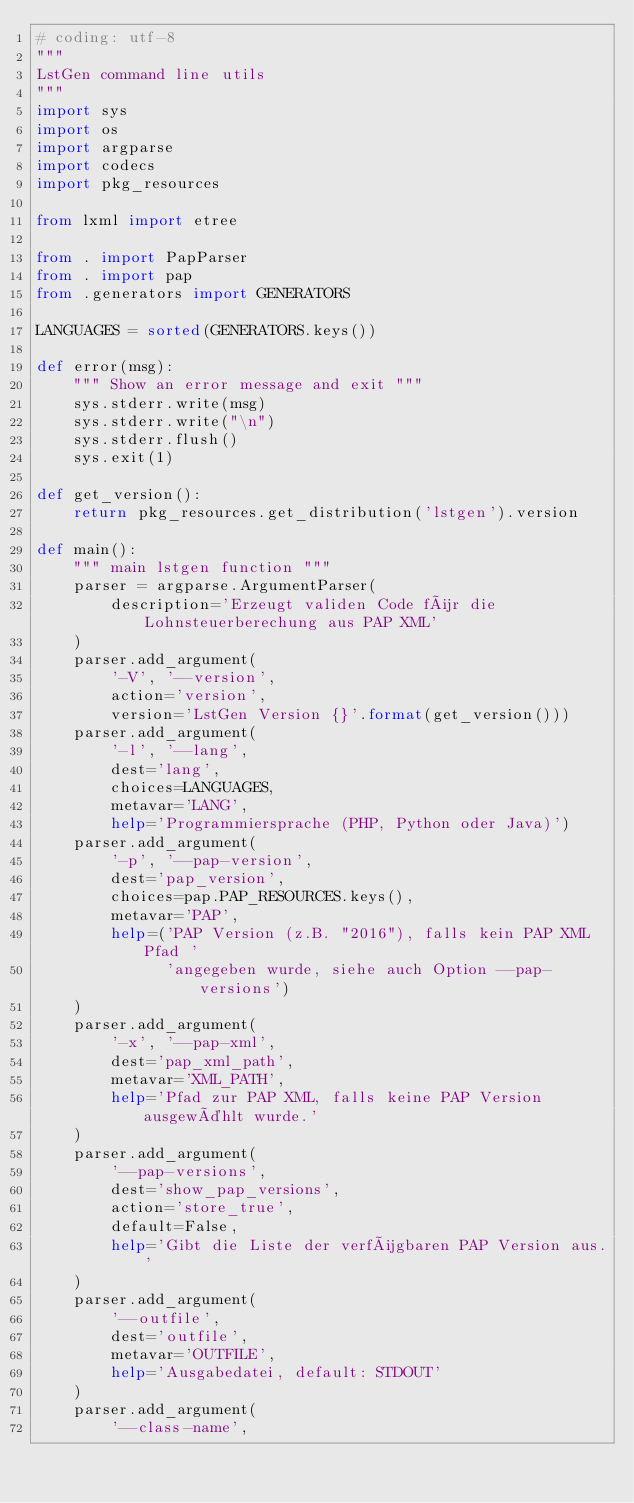<code> <loc_0><loc_0><loc_500><loc_500><_Python_># coding: utf-8
"""
LstGen command line utils
"""
import sys
import os
import argparse
import codecs
import pkg_resources

from lxml import etree

from . import PapParser
from . import pap
from .generators import GENERATORS

LANGUAGES = sorted(GENERATORS.keys())

def error(msg):
    """ Show an error message and exit """
    sys.stderr.write(msg)
    sys.stderr.write("\n")
    sys.stderr.flush()
    sys.exit(1)

def get_version():
    return pkg_resources.get_distribution('lstgen').version

def main():
    """ main lstgen function """
    parser = argparse.ArgumentParser(
        description='Erzeugt validen Code für die Lohnsteuerberechung aus PAP XML'
    )
    parser.add_argument(
        '-V', '--version',
        action='version',
        version='LstGen Version {}'.format(get_version()))
    parser.add_argument(
        '-l', '--lang',
        dest='lang',
        choices=LANGUAGES,
        metavar='LANG',
        help='Programmiersprache (PHP, Python oder Java)')
    parser.add_argument(
        '-p', '--pap-version',
        dest='pap_version',
        choices=pap.PAP_RESOURCES.keys(),
        metavar='PAP',
        help=('PAP Version (z.B. "2016"), falls kein PAP XML Pfad '
              'angegeben wurde, siehe auch Option --pap-versions')
    )
    parser.add_argument(
        '-x', '--pap-xml',
        dest='pap_xml_path',
        metavar='XML_PATH',
        help='Pfad zur PAP XML, falls keine PAP Version ausgewählt wurde.'
    )
    parser.add_argument(
        '--pap-versions',
        dest='show_pap_versions',
        action='store_true',
        default=False,
        help='Gibt die Liste der verfügbaren PAP Version aus.'
    )
    parser.add_argument(
        '--outfile',
        dest='outfile',
        metavar='OUTFILE',
        help='Ausgabedatei, default: STDOUT'
    )
    parser.add_argument(
        '--class-name',</code> 